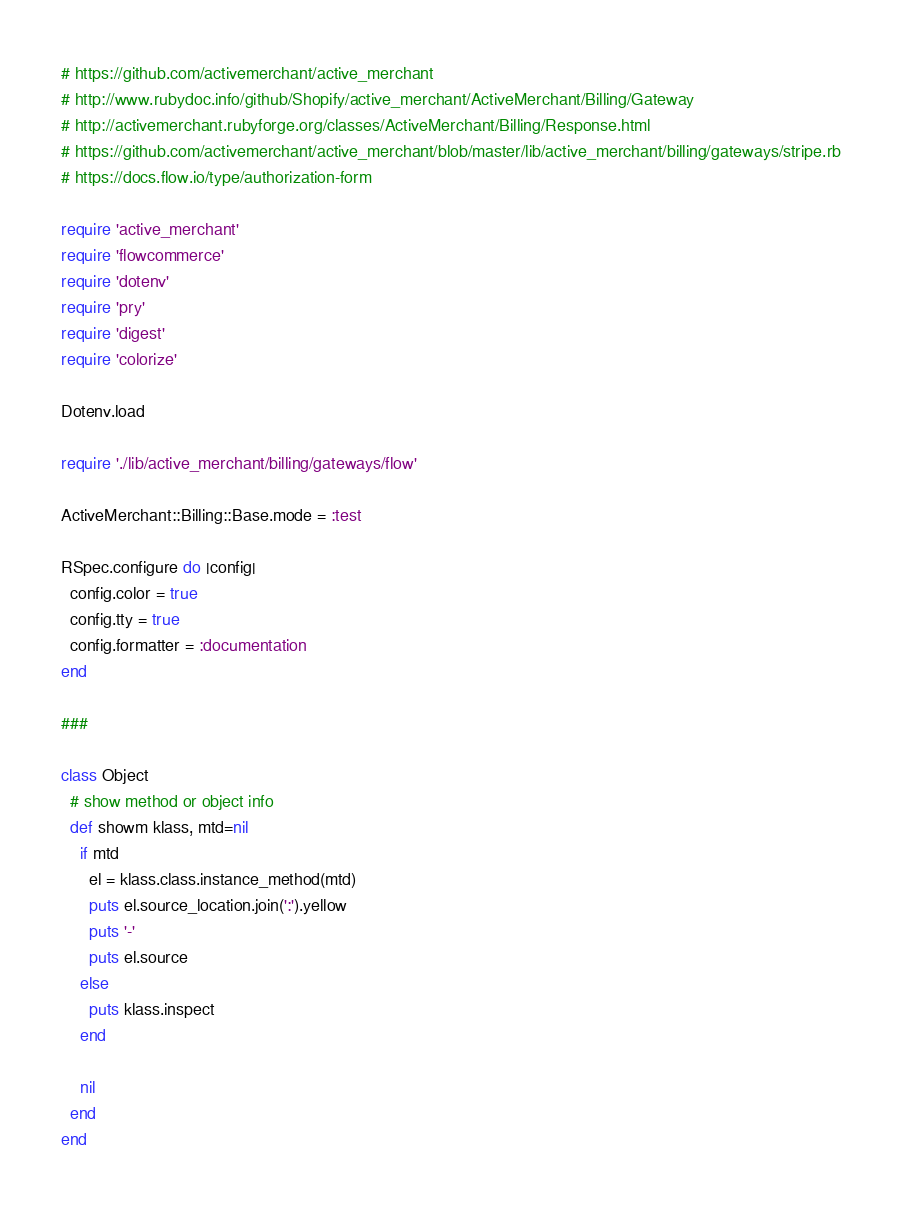Convert code to text. <code><loc_0><loc_0><loc_500><loc_500><_Ruby_># https://github.com/activemerchant/active_merchant
# http://www.rubydoc.info/github/Shopify/active_merchant/ActiveMerchant/Billing/Gateway
# http://activemerchant.rubyforge.org/classes/ActiveMerchant/Billing/Response.html
# https://github.com/activemerchant/active_merchant/blob/master/lib/active_merchant/billing/gateways/stripe.rb
# https://docs.flow.io/type/authorization-form

require 'active_merchant'
require 'flowcommerce'
require 'dotenv'
require 'pry'
require 'digest'
require 'colorize'

Dotenv.load

require './lib/active_merchant/billing/gateways/flow'

ActiveMerchant::Billing::Base.mode = :test

RSpec.configure do |config|
  config.color = true
  config.tty = true
  config.formatter = :documentation
end

###

class Object
  # show method or object info
  def showm klass, mtd=nil
    if mtd
      el = klass.class.instance_method(mtd)
      puts el.source_location.join(':').yellow
      puts '-'
      puts el.source
    else
      puts klass.inspect
    end

    nil
  end
end
</code> 